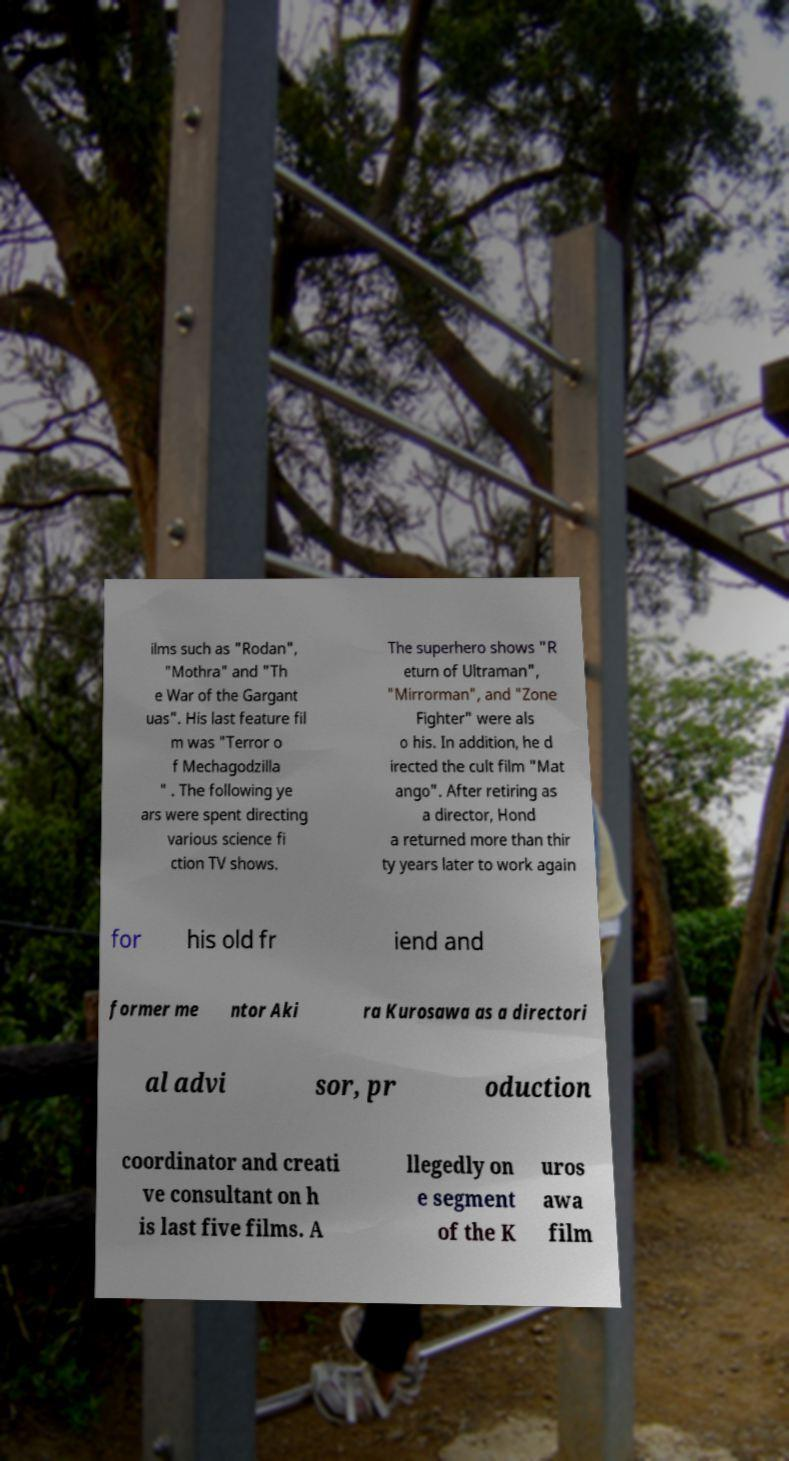What messages or text are displayed in this image? I need them in a readable, typed format. ilms such as "Rodan", "Mothra" and "Th e War of the Gargant uas". His last feature fil m was "Terror o f Mechagodzilla " . The following ye ars were spent directing various science fi ction TV shows. The superhero shows "R eturn of Ultraman", "Mirrorman", and "Zone Fighter" were als o his. In addition, he d irected the cult film "Mat ango". After retiring as a director, Hond a returned more than thir ty years later to work again for his old fr iend and former me ntor Aki ra Kurosawa as a directori al advi sor, pr oduction coordinator and creati ve consultant on h is last five films. A llegedly on e segment of the K uros awa film 